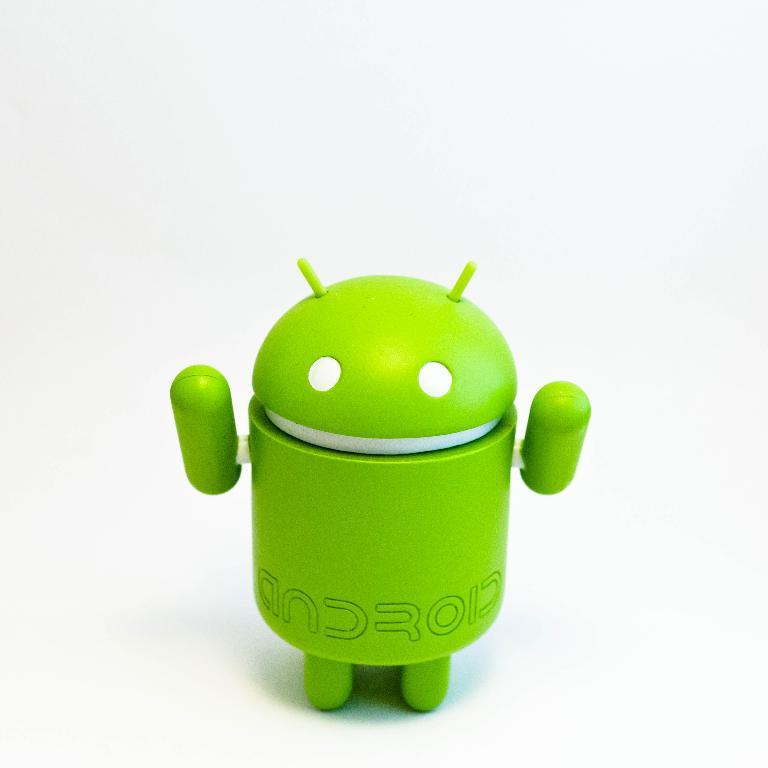What brand is this?
Keep it short and to the point. Android. 